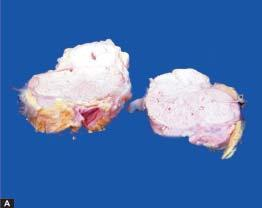s chematic representation of mechanisms surrounded by increased fat?
Answer the question using a single word or phrase. No 